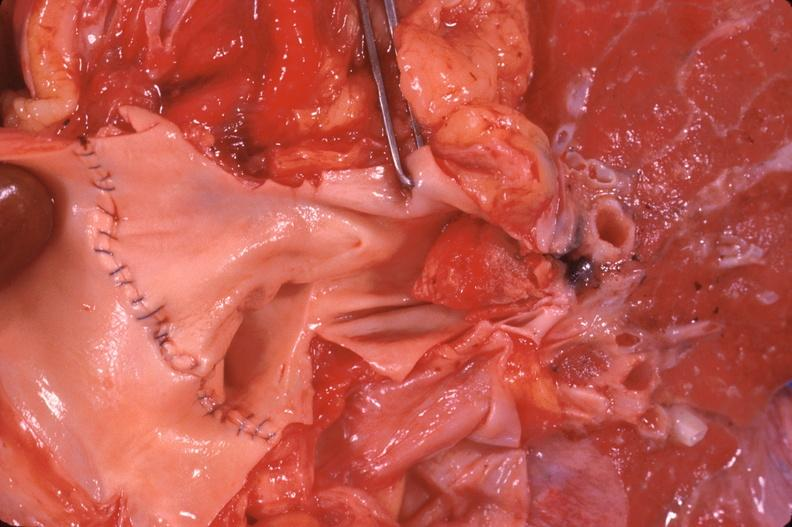s respiratory present?
Answer the question using a single word or phrase. Yes 